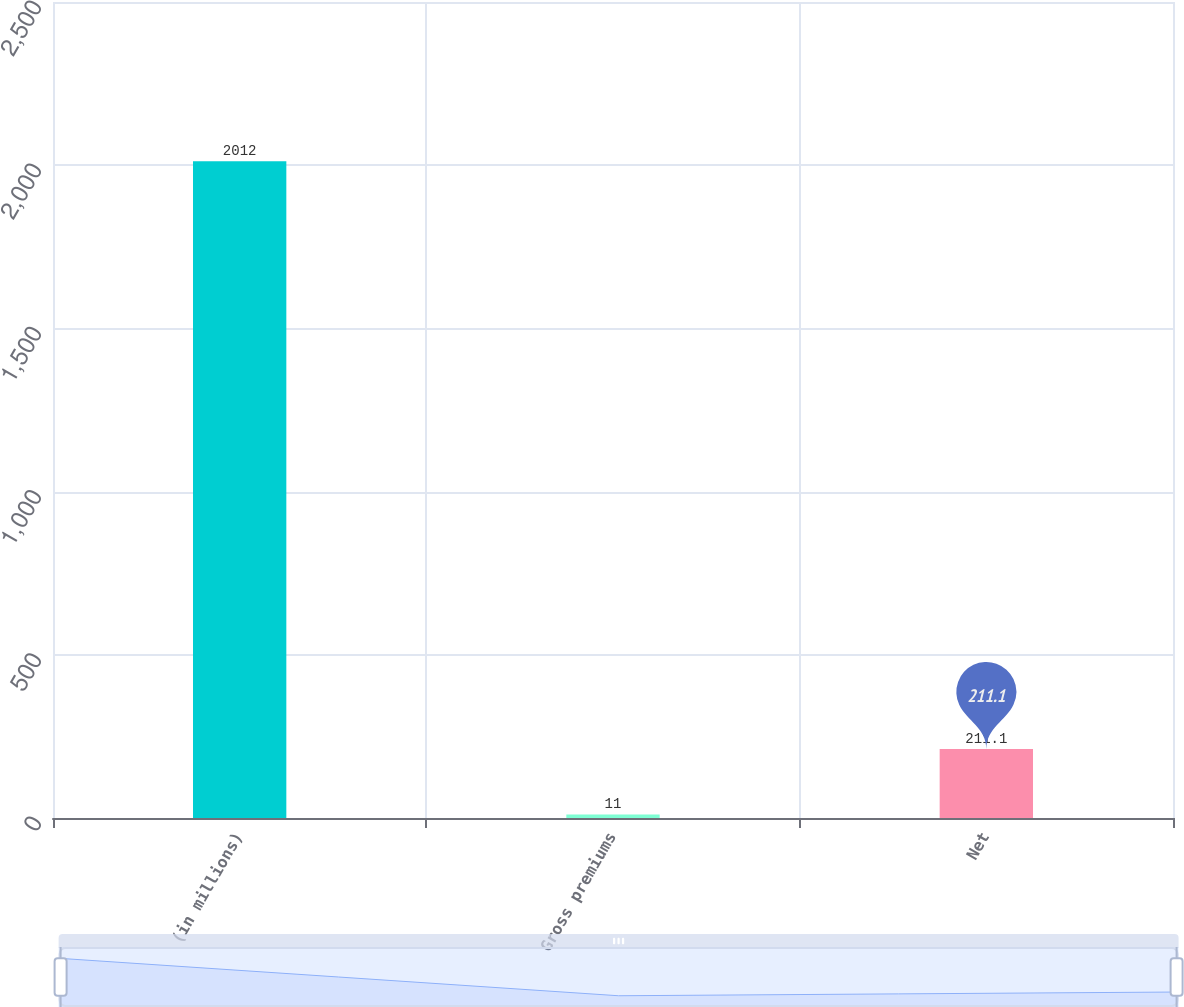Convert chart to OTSL. <chart><loc_0><loc_0><loc_500><loc_500><bar_chart><fcel>(in millions)<fcel>Gross premiums<fcel>Net<nl><fcel>2012<fcel>11<fcel>211.1<nl></chart> 